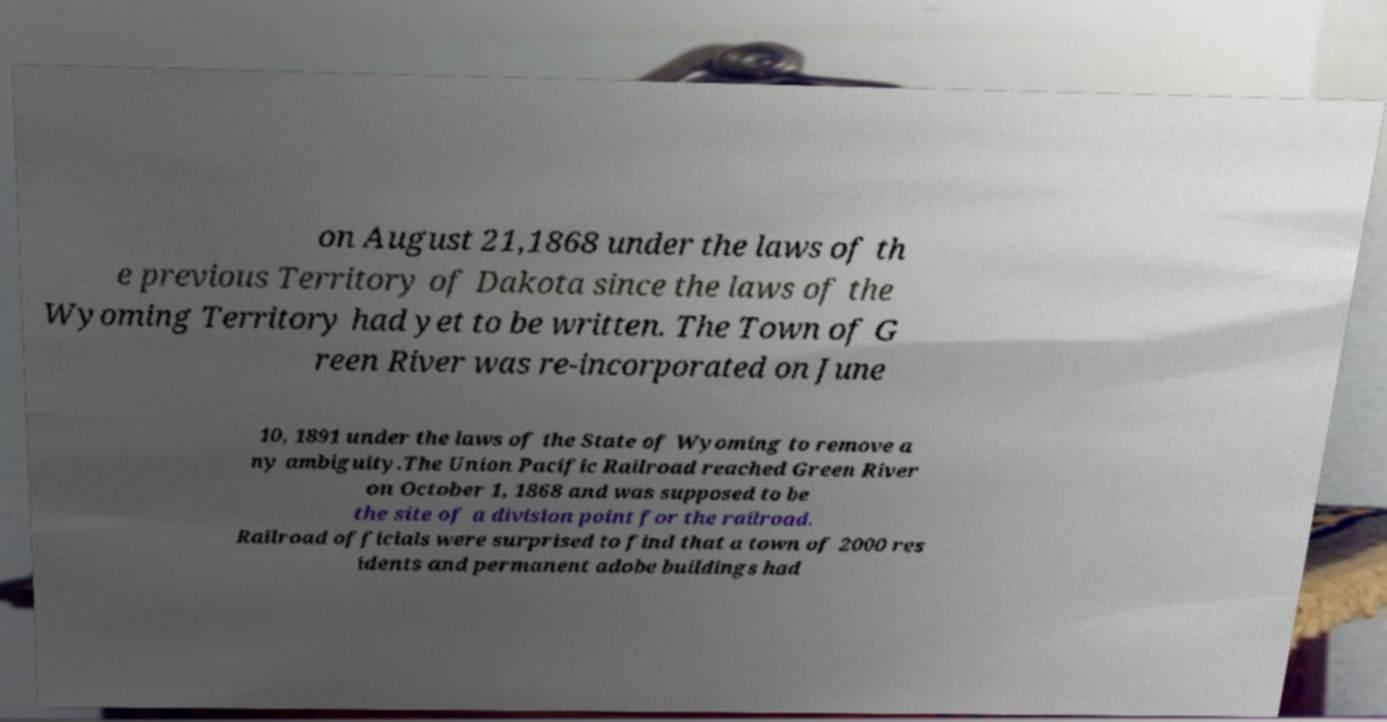There's text embedded in this image that I need extracted. Can you transcribe it verbatim? on August 21,1868 under the laws of th e previous Territory of Dakota since the laws of the Wyoming Territory had yet to be written. The Town of G reen River was re-incorporated on June 10, 1891 under the laws of the State of Wyoming to remove a ny ambiguity.The Union Pacific Railroad reached Green River on October 1, 1868 and was supposed to be the site of a division point for the railroad. Railroad officials were surprised to find that a town of 2000 res idents and permanent adobe buildings had 